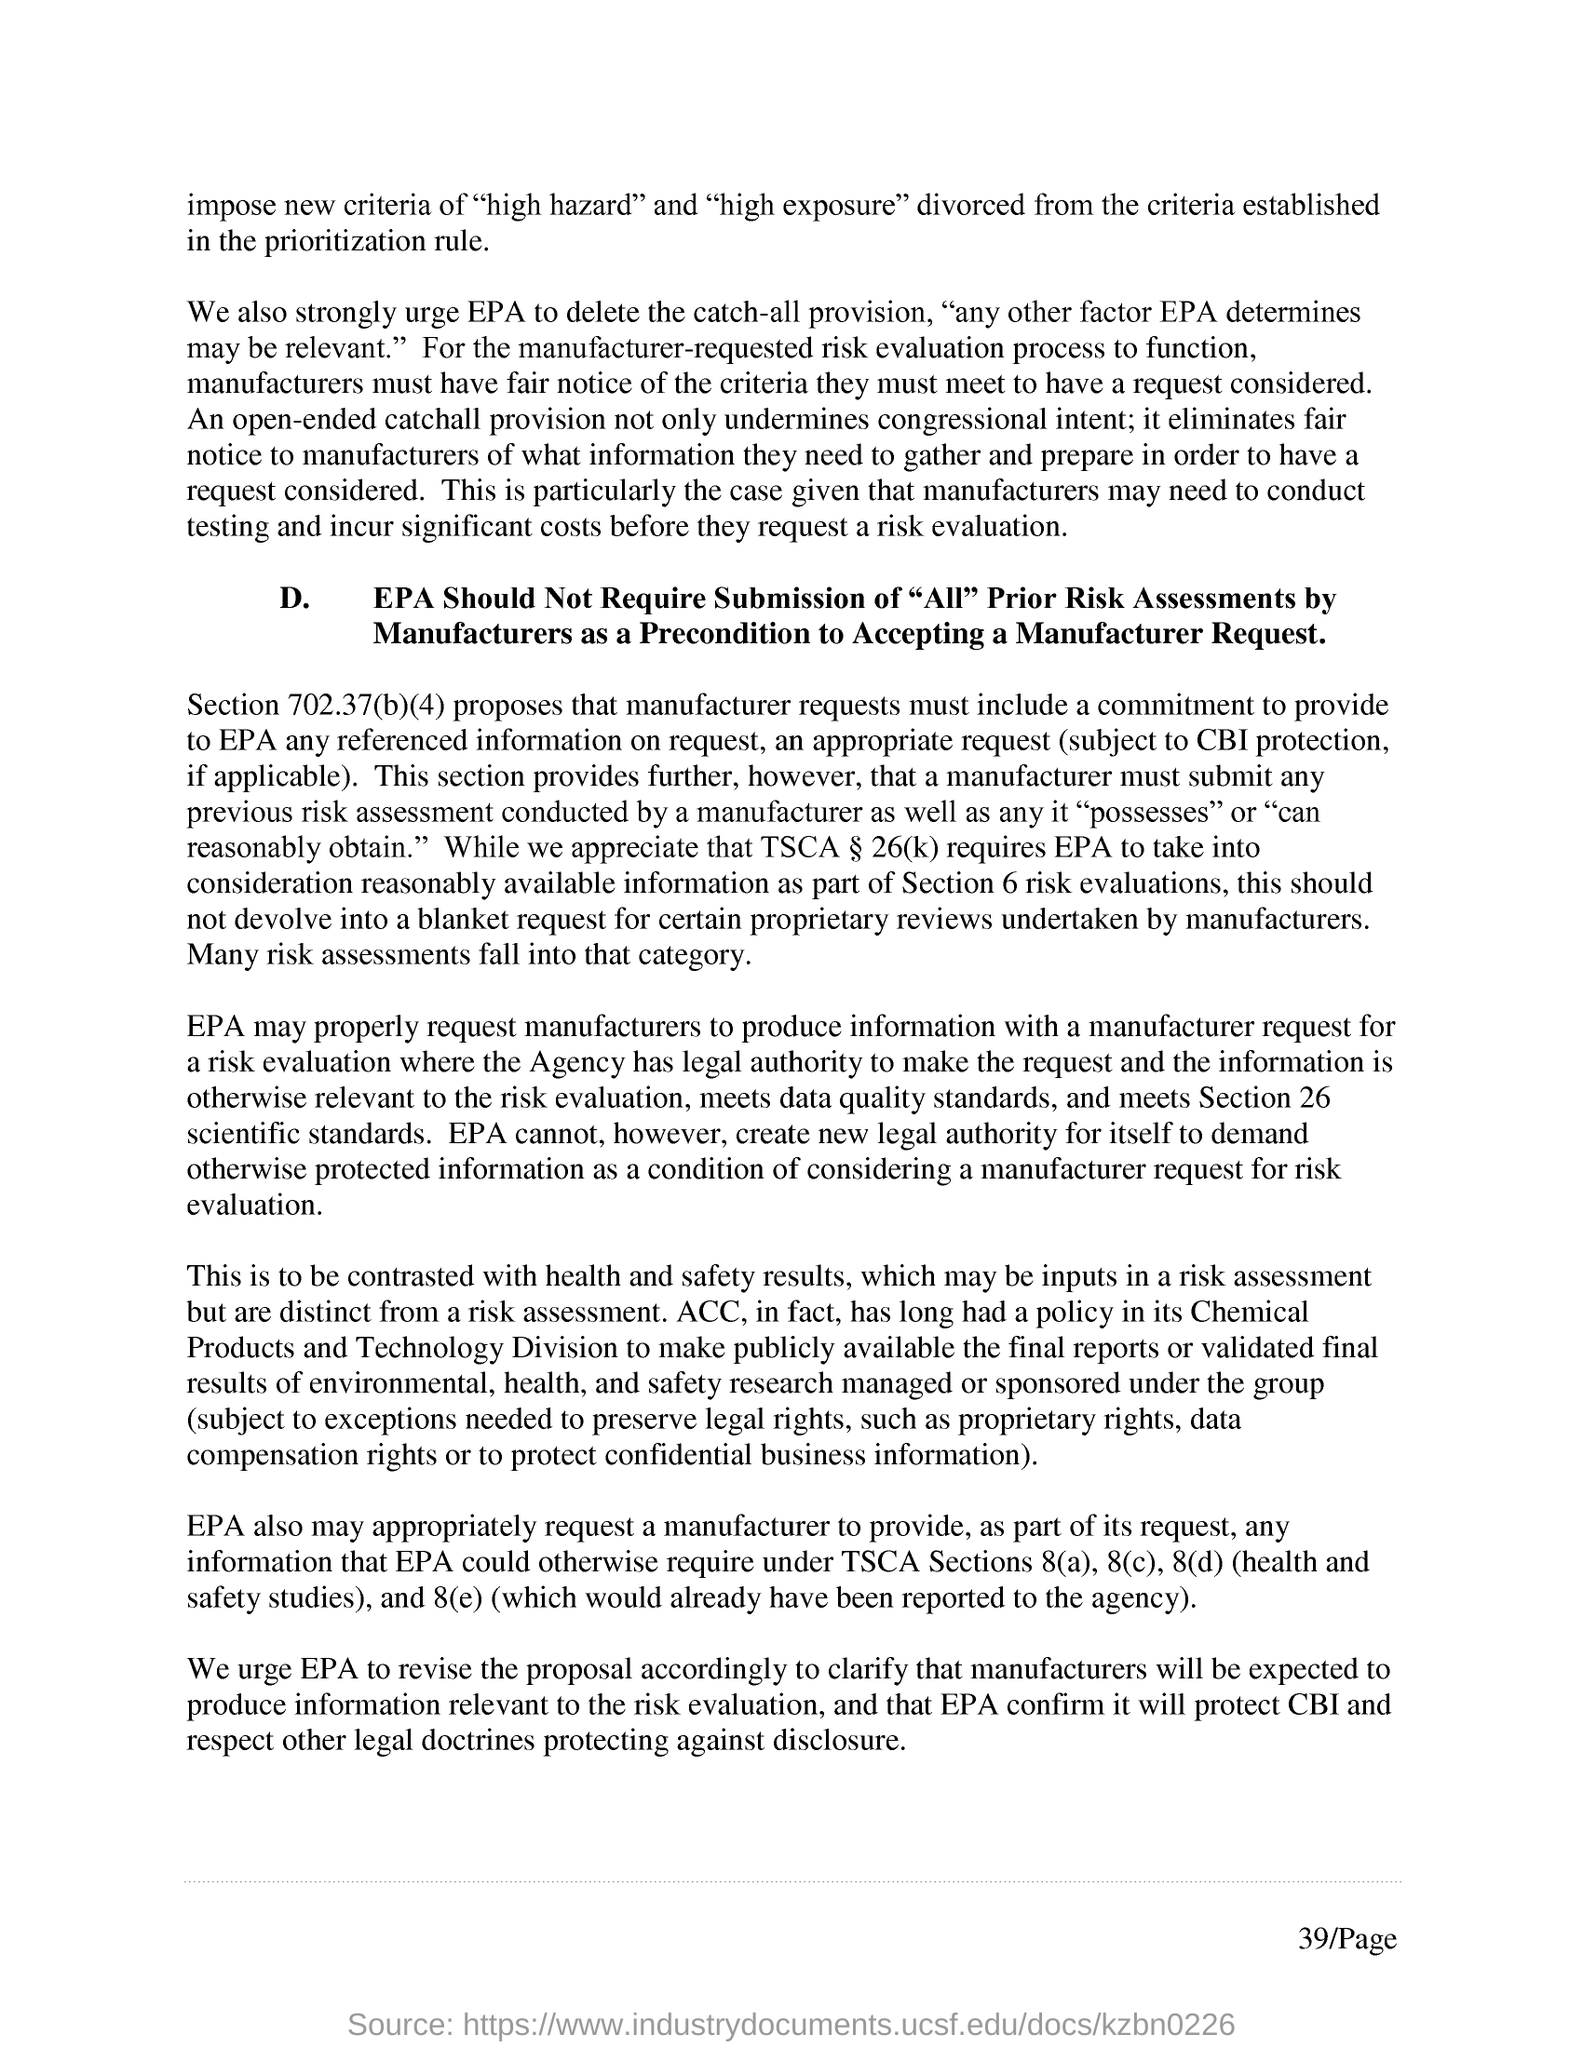Mention a couple of crucial points in this snapshot. Section 702.37(b)(4) is mentioned in the first paragraph of D. 